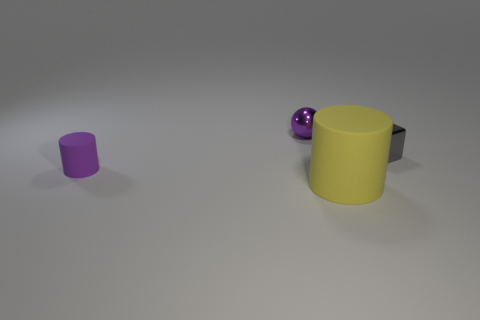Add 2 metal blocks. How many objects exist? 6 Subtract all spheres. How many objects are left? 3 Add 4 small spheres. How many small spheres exist? 5 Subtract 0 red blocks. How many objects are left? 4 Subtract all large things. Subtract all purple cylinders. How many objects are left? 2 Add 4 purple metal balls. How many purple metal balls are left? 5 